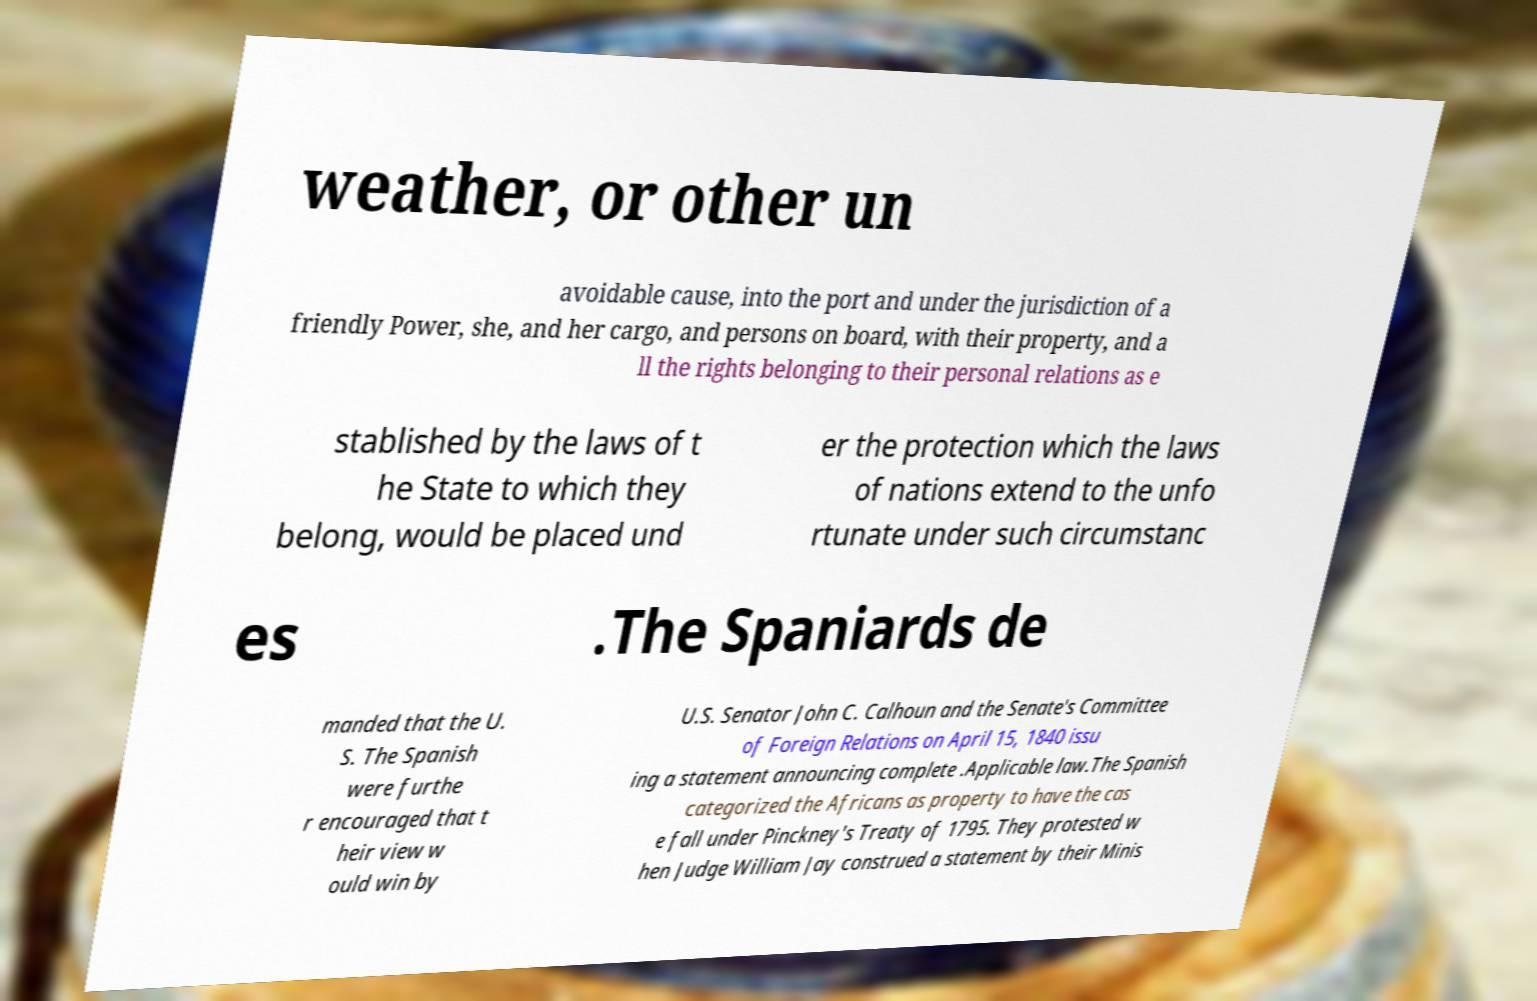Please read and relay the text visible in this image. What does it say? weather, or other un avoidable cause, into the port and under the jurisdiction of a friendly Power, she, and her cargo, and persons on board, with their property, and a ll the rights belonging to their personal relations as e stablished by the laws of t he State to which they belong, would be placed und er the protection which the laws of nations extend to the unfo rtunate under such circumstanc es .The Spaniards de manded that the U. S. The Spanish were furthe r encouraged that t heir view w ould win by U.S. Senator John C. Calhoun and the Senate's Committee of Foreign Relations on April 15, 1840 issu ing a statement announcing complete .Applicable law.The Spanish categorized the Africans as property to have the cas e fall under Pinckney's Treaty of 1795. They protested w hen Judge William Jay construed a statement by their Minis 